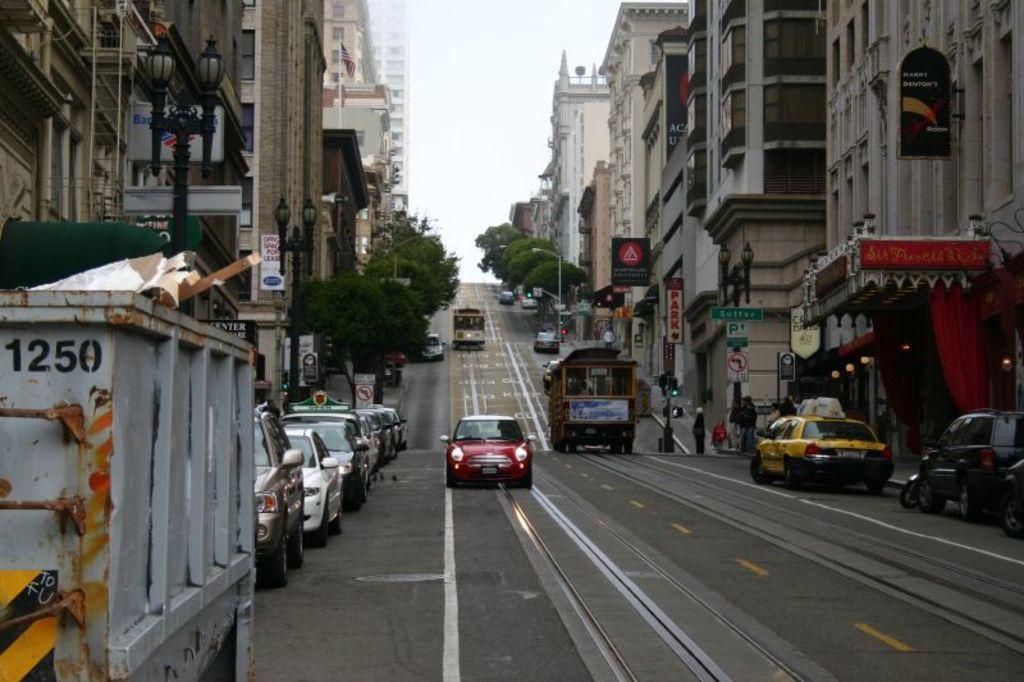What four digit number is on the corner of the truck?
Offer a terse response. 1250. What color is the small car in the middle of the street?
Give a very brief answer. Red. 